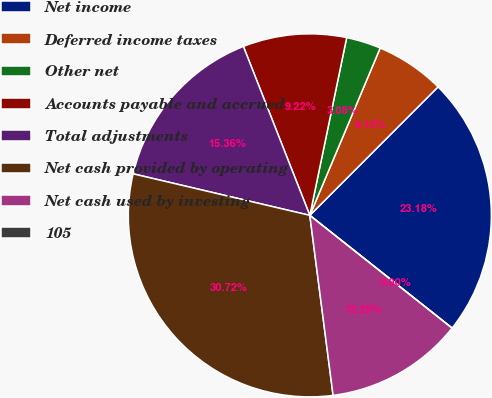Convert chart. <chart><loc_0><loc_0><loc_500><loc_500><pie_chart><fcel>Net income<fcel>Deferred income taxes<fcel>Other net<fcel>Accounts payable and accrued<fcel>Total adjustments<fcel>Net cash provided by operating<fcel>Net cash used by investing<fcel>105<nl><fcel>23.18%<fcel>6.15%<fcel>3.08%<fcel>9.22%<fcel>15.36%<fcel>30.72%<fcel>12.29%<fcel>0.0%<nl></chart> 